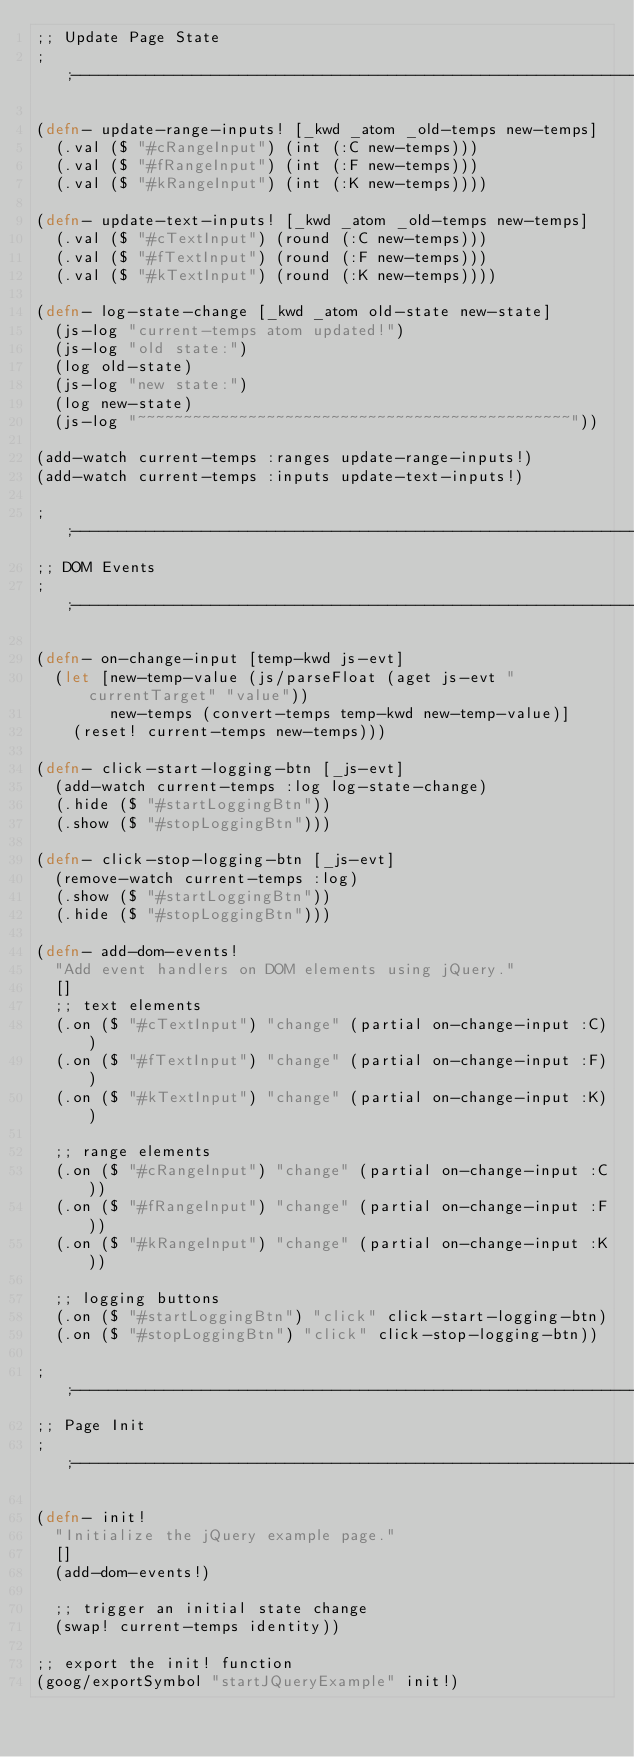<code> <loc_0><loc_0><loc_500><loc_500><_Clojure_>;; Update Page State
;;------------------------------------------------------------------------------

(defn- update-range-inputs! [_kwd _atom _old-temps new-temps]
  (.val ($ "#cRangeInput") (int (:C new-temps)))
  (.val ($ "#fRangeInput") (int (:F new-temps)))
  (.val ($ "#kRangeInput") (int (:K new-temps))))

(defn- update-text-inputs! [_kwd _atom _old-temps new-temps]
  (.val ($ "#cTextInput") (round (:C new-temps)))
  (.val ($ "#fTextInput") (round (:F new-temps)))
  (.val ($ "#kTextInput") (round (:K new-temps))))

(defn- log-state-change [_kwd _atom old-state new-state]
  (js-log "current-temps atom updated!")
  (js-log "old state:")
  (log old-state)
  (js-log "new state:")
  (log new-state)
  (js-log "~~~~~~~~~~~~~~~~~~~~~~~~~~~~~~~~~~~~~~~~~~~~~~~"))

(add-watch current-temps :ranges update-range-inputs!)
(add-watch current-temps :inputs update-text-inputs!)

;;------------------------------------------------------------------------------
;; DOM Events
;;------------------------------------------------------------------------------

(defn- on-change-input [temp-kwd js-evt]
  (let [new-temp-value (js/parseFloat (aget js-evt "currentTarget" "value"))
        new-temps (convert-temps temp-kwd new-temp-value)]
    (reset! current-temps new-temps)))

(defn- click-start-logging-btn [_js-evt]
  (add-watch current-temps :log log-state-change)
  (.hide ($ "#startLoggingBtn"))
  (.show ($ "#stopLoggingBtn")))

(defn- click-stop-logging-btn [_js-evt]
  (remove-watch current-temps :log)
  (.show ($ "#startLoggingBtn"))
  (.hide ($ "#stopLoggingBtn")))

(defn- add-dom-events!
  "Add event handlers on DOM elements using jQuery."
  []
  ;; text elements
  (.on ($ "#cTextInput") "change" (partial on-change-input :C))
  (.on ($ "#fTextInput") "change" (partial on-change-input :F))
  (.on ($ "#kTextInput") "change" (partial on-change-input :K))

  ;; range elements
  (.on ($ "#cRangeInput") "change" (partial on-change-input :C))
  (.on ($ "#fRangeInput") "change" (partial on-change-input :F))
  (.on ($ "#kRangeInput") "change" (partial on-change-input :K))

  ;; logging buttons
  (.on ($ "#startLoggingBtn") "click" click-start-logging-btn)
  (.on ($ "#stopLoggingBtn") "click" click-stop-logging-btn))

;;------------------------------------------------------------------------------
;; Page Init
;;------------------------------------------------------------------------------

(defn- init!
  "Initialize the jQuery example page."
  []
  (add-dom-events!)

  ;; trigger an initial state change
  (swap! current-temps identity))

;; export the init! function
(goog/exportSymbol "startJQueryExample" init!)
</code> 